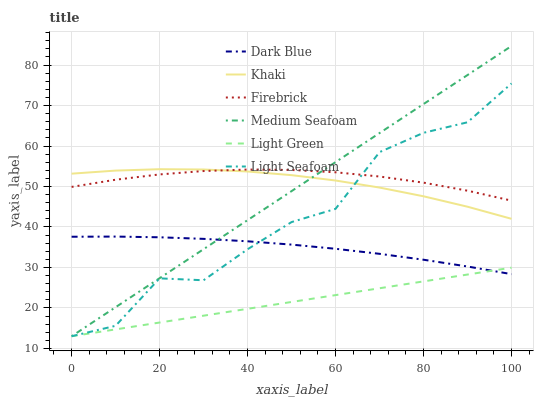Does Light Green have the minimum area under the curve?
Answer yes or no. Yes. Does Firebrick have the maximum area under the curve?
Answer yes or no. Yes. Does Dark Blue have the minimum area under the curve?
Answer yes or no. No. Does Dark Blue have the maximum area under the curve?
Answer yes or no. No. Is Light Green the smoothest?
Answer yes or no. Yes. Is Light Seafoam the roughest?
Answer yes or no. Yes. Is Firebrick the smoothest?
Answer yes or no. No. Is Firebrick the roughest?
Answer yes or no. No. Does Light Green have the lowest value?
Answer yes or no. Yes. Does Dark Blue have the lowest value?
Answer yes or no. No. Does Medium Seafoam have the highest value?
Answer yes or no. Yes. Does Firebrick have the highest value?
Answer yes or no. No. Is Dark Blue less than Firebrick?
Answer yes or no. Yes. Is Firebrick greater than Light Green?
Answer yes or no. Yes. Does Khaki intersect Medium Seafoam?
Answer yes or no. Yes. Is Khaki less than Medium Seafoam?
Answer yes or no. No. Is Khaki greater than Medium Seafoam?
Answer yes or no. No. Does Dark Blue intersect Firebrick?
Answer yes or no. No. 